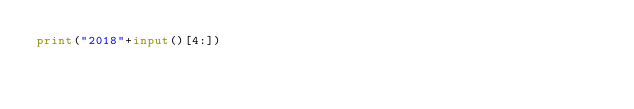Convert code to text. <code><loc_0><loc_0><loc_500><loc_500><_Python_>print("2018"+input()[4:])</code> 